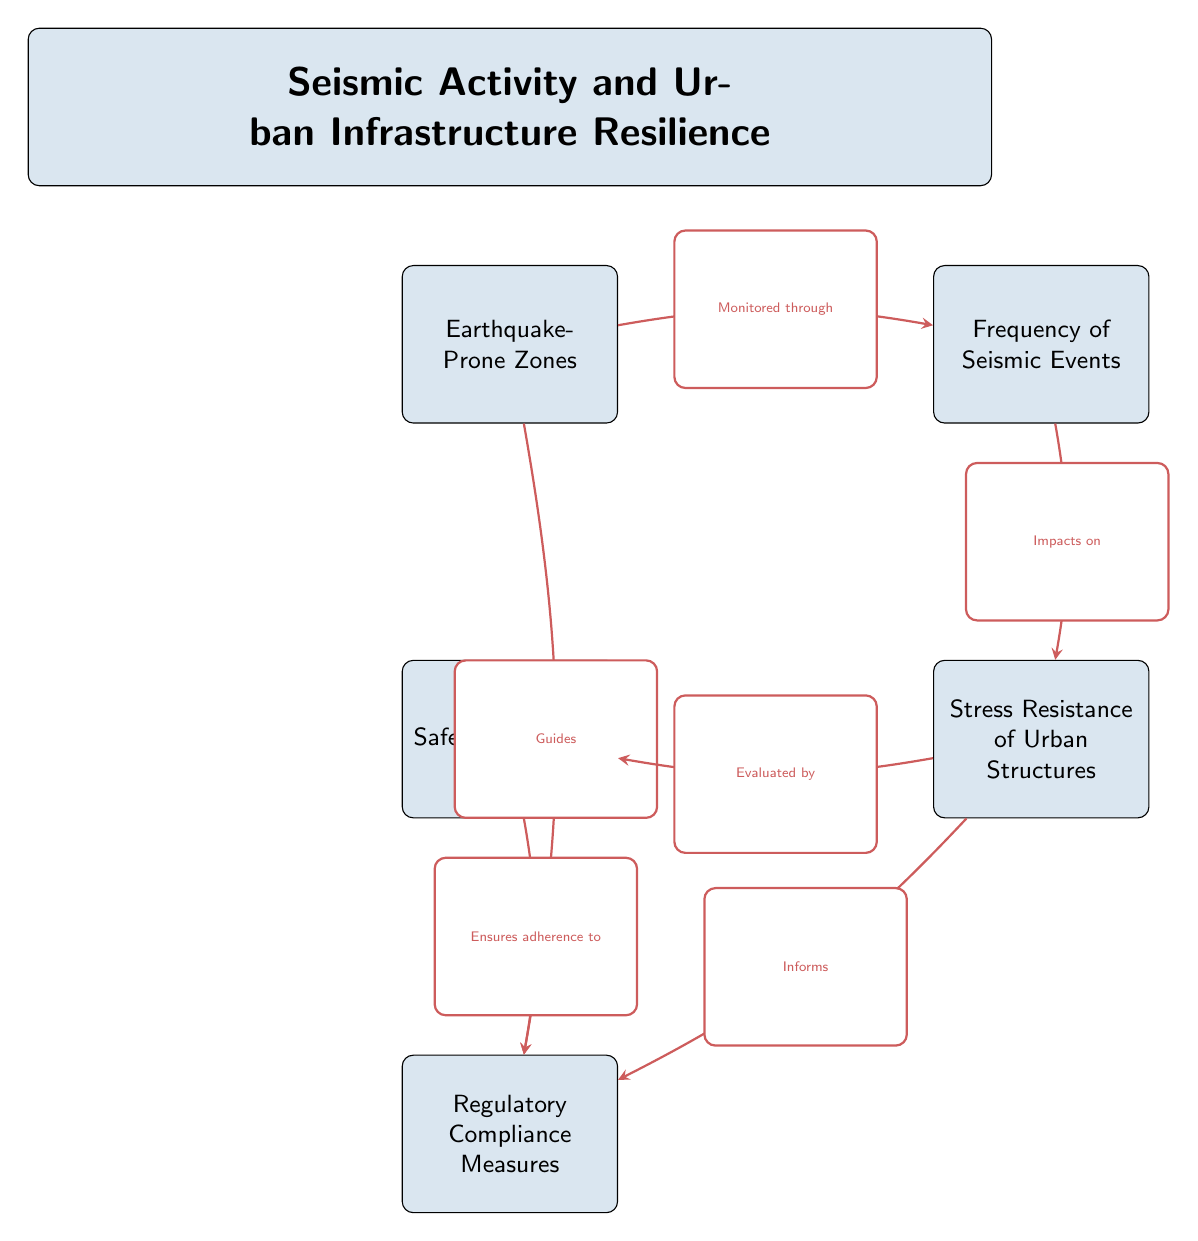What are the three main nodes in the diagram? The diagram consists of five nodes, but the question asks for the three main nodes, which can be determined by looking at the layout of the nodes. The primary focus appears to be on 'Earthquake-Prone Zones', 'Frequency of Seismic Events', and 'Stress Resistance of Urban Structures' as they are central to the theme.
Answer: Earthquake-Prone Zones, Frequency of Seismic Events, Stress Resistance of Urban Structures How many edges are present in the diagram? By counting the arrows (edges) connecting the nodes, we see that there are a total of six edges connecting different pairs of nodes.
Answer: 6 What does 'Earthquake-Prone Zones' guide? The arrow indicates that 'Earthquake-Prone Zones' guides 'Regulatory Compliance Measures'. This relationship is visualized by the arrow connecting these two nodes, with the connecting label clearly indicating the guiding role.
Answer: Regulatory Compliance Measures Which node is evaluated by the 'Safety Inspections' node? From the diagram, 'Stress Resistance of Urban Structures' is the node that is evaluated by 'Safety Inspections', as indicated by the arrow connecting these two nodes, which denotes an evaluative relationship.
Answer: Stress Resistance of Urban Structures What type of relationship exists between 'Frequency of Seismic Events' and 'Stress Resistance of Urban Structures'? The diagram shows a direct impact relationship where 'Frequency of Seismic Events' affects or has an impact on 'Stress Resistance of Urban Structures', indicated by the arrow labeled accordingly.
Answer: Impacts on 